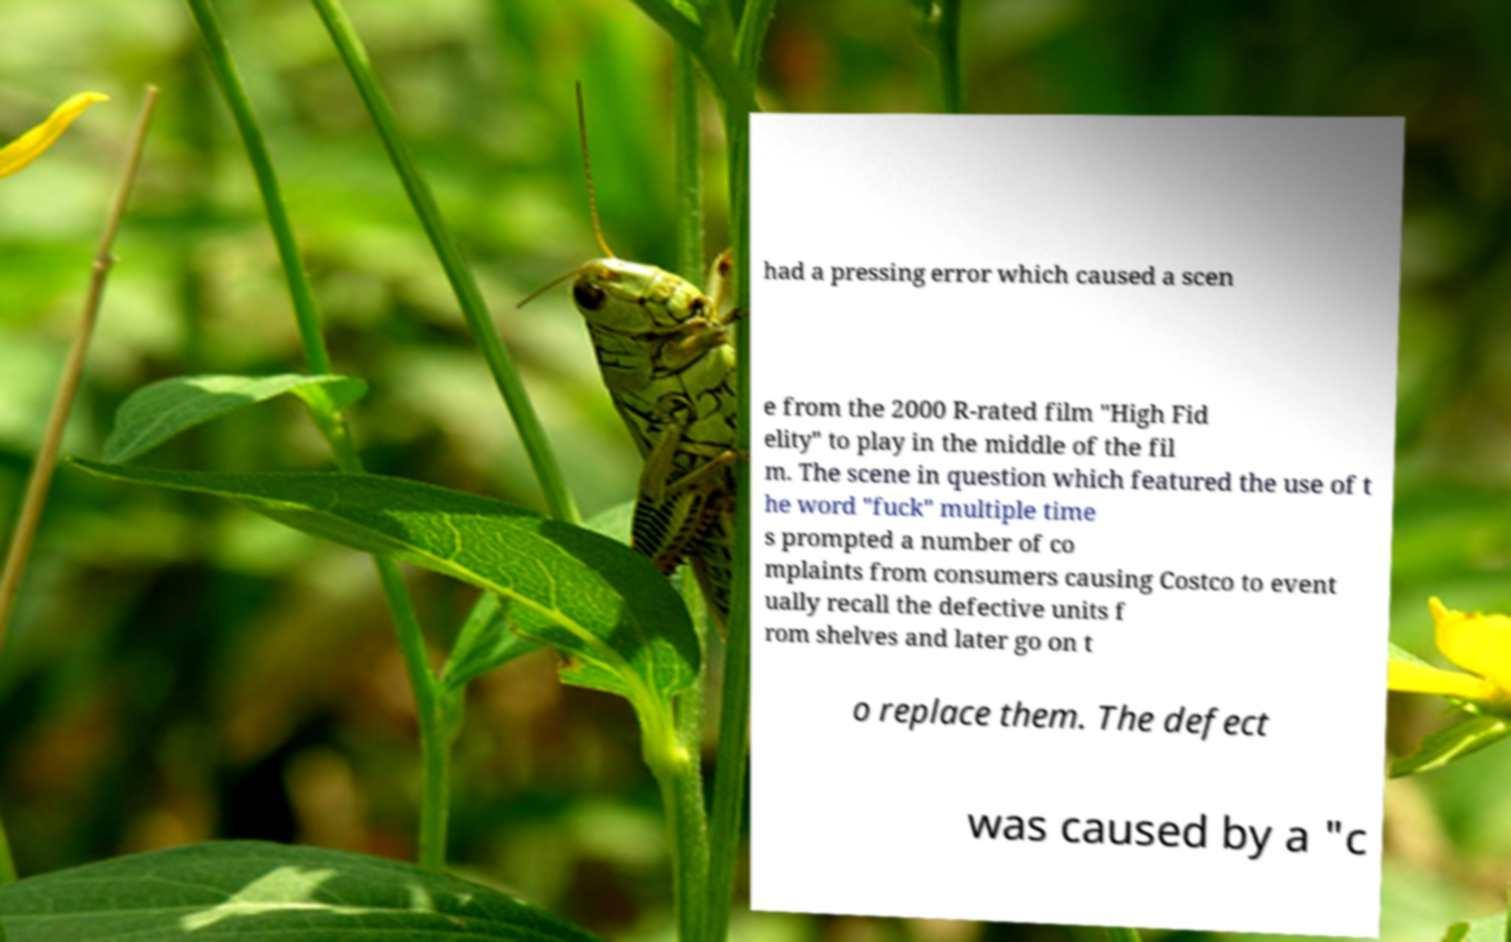Please read and relay the text visible in this image. What does it say? had a pressing error which caused a scen e from the 2000 R-rated film "High Fid elity" to play in the middle of the fil m. The scene in question which featured the use of t he word "fuck" multiple time s prompted a number of co mplaints from consumers causing Costco to event ually recall the defective units f rom shelves and later go on t o replace them. The defect was caused by a "c 